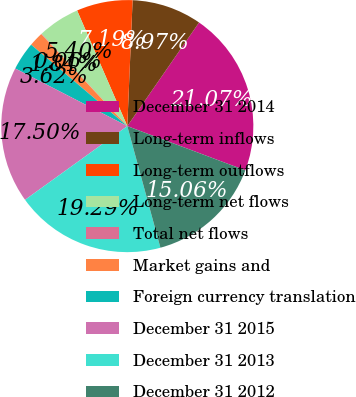Convert chart. <chart><loc_0><loc_0><loc_500><loc_500><pie_chart><fcel>December 31 2014<fcel>Long-term inflows<fcel>Long-term outflows<fcel>Long-term net flows<fcel>Total net flows<fcel>Market gains and<fcel>Foreign currency translation<fcel>December 31 2015<fcel>December 31 2013<fcel>December 31 2012<nl><fcel>21.07%<fcel>8.97%<fcel>7.19%<fcel>5.4%<fcel>0.06%<fcel>1.84%<fcel>3.62%<fcel>17.5%<fcel>19.29%<fcel>15.06%<nl></chart> 